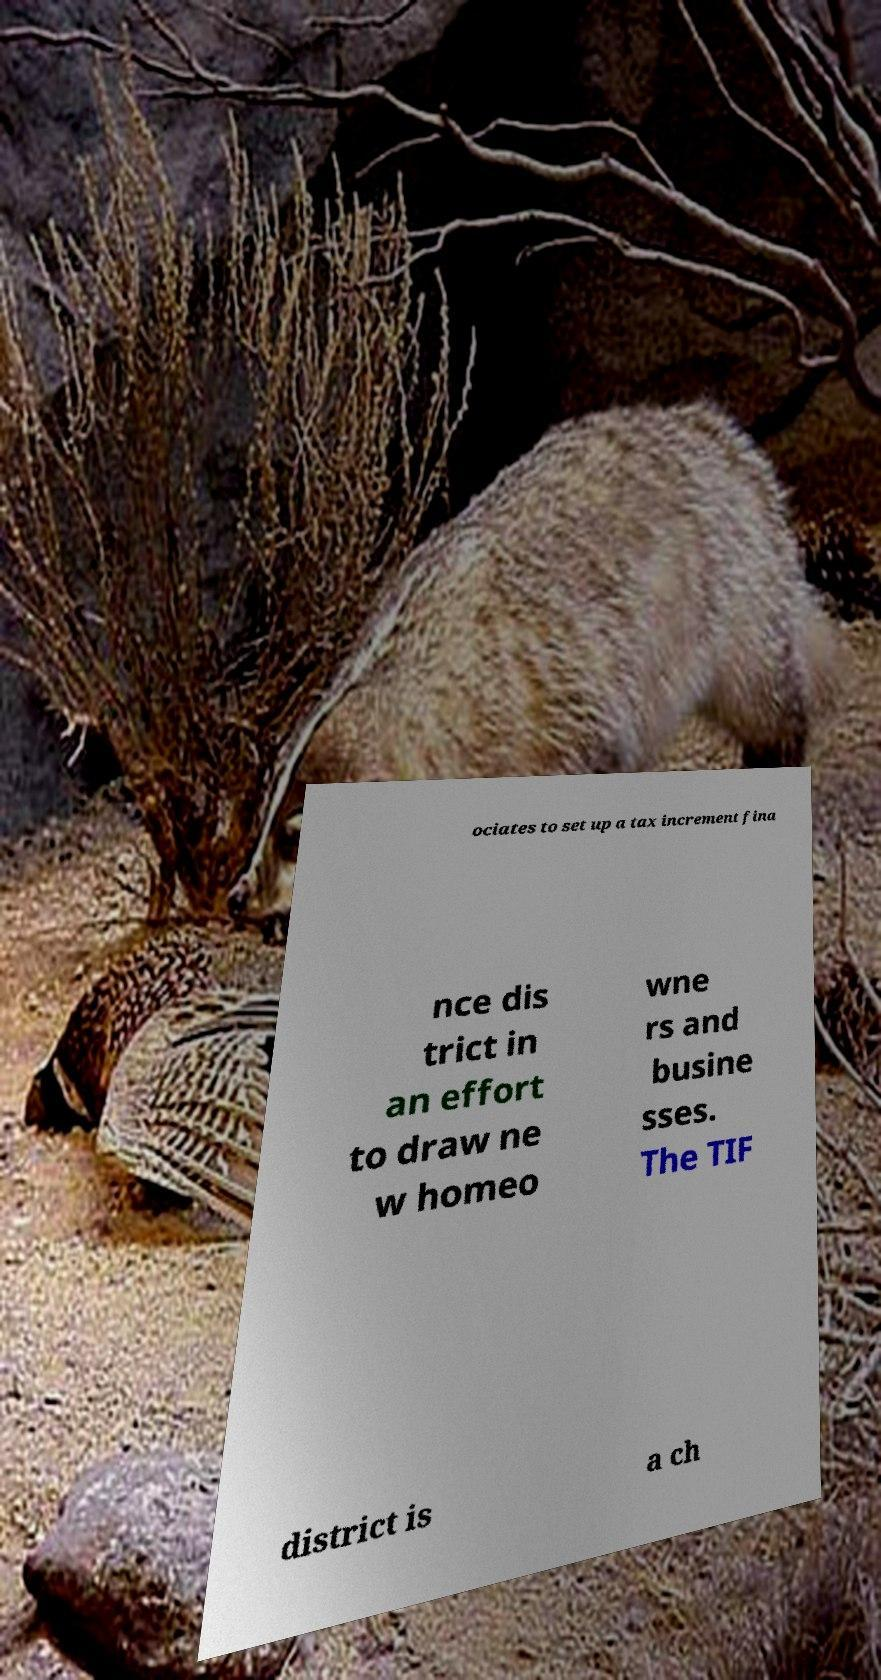Can you accurately transcribe the text from the provided image for me? ociates to set up a tax increment fina nce dis trict in an effort to draw ne w homeo wne rs and busine sses. The TIF district is a ch 